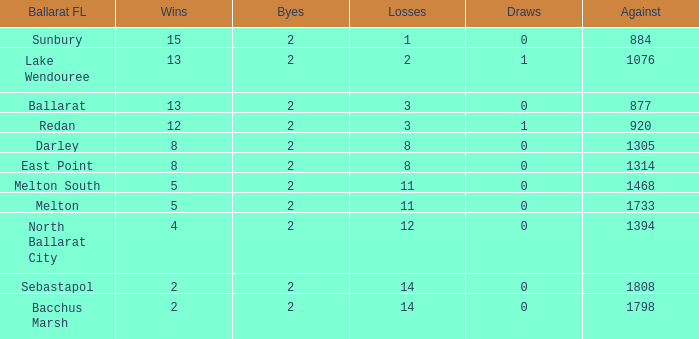How many defeats does a ballarat fl of melton south have, with an opposed greater than 1468? 0.0. 